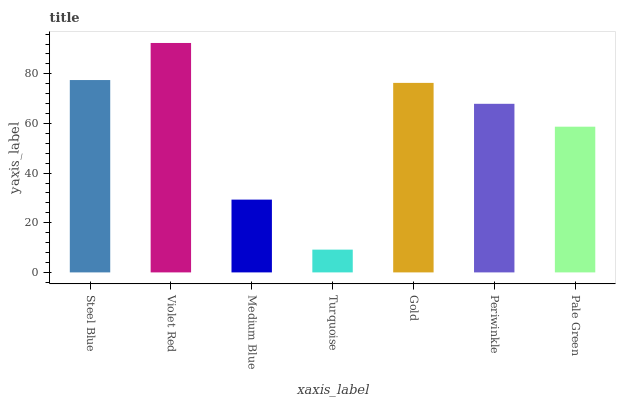Is Turquoise the minimum?
Answer yes or no. Yes. Is Violet Red the maximum?
Answer yes or no. Yes. Is Medium Blue the minimum?
Answer yes or no. No. Is Medium Blue the maximum?
Answer yes or no. No. Is Violet Red greater than Medium Blue?
Answer yes or no. Yes. Is Medium Blue less than Violet Red?
Answer yes or no. Yes. Is Medium Blue greater than Violet Red?
Answer yes or no. No. Is Violet Red less than Medium Blue?
Answer yes or no. No. Is Periwinkle the high median?
Answer yes or no. Yes. Is Periwinkle the low median?
Answer yes or no. Yes. Is Medium Blue the high median?
Answer yes or no. No. Is Pale Green the low median?
Answer yes or no. No. 